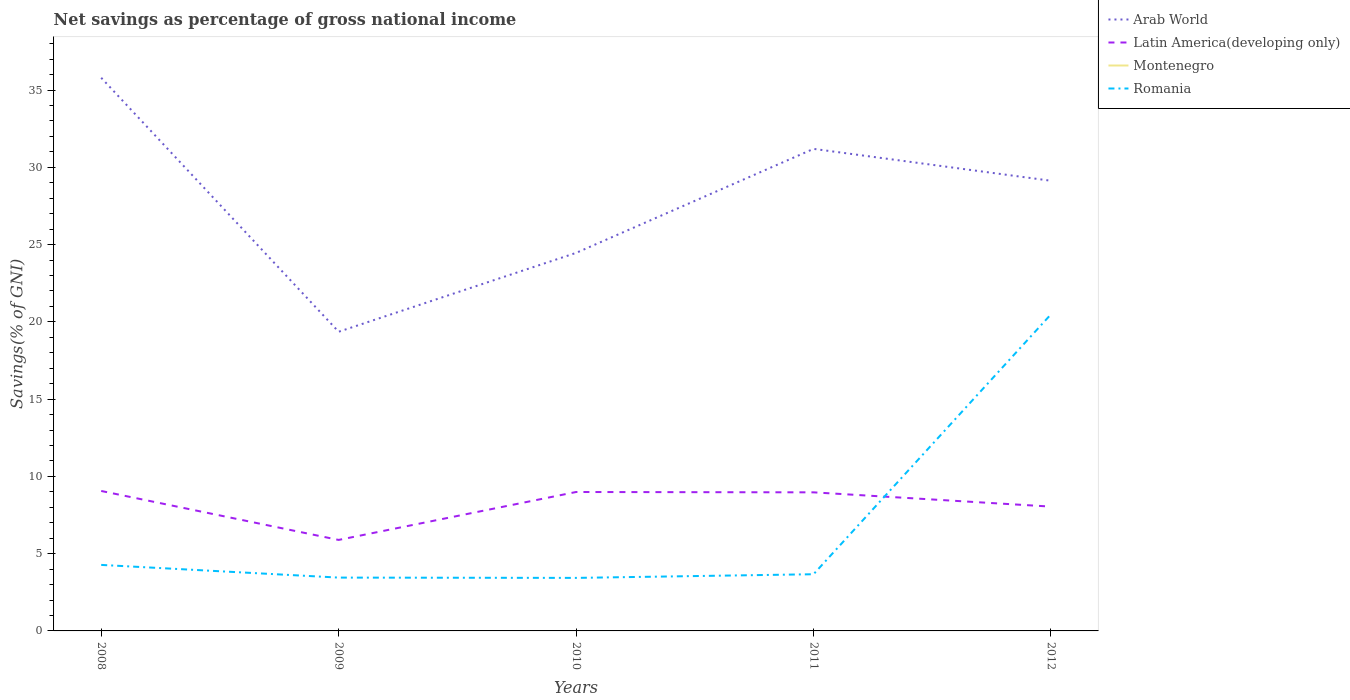Across all years, what is the maximum total savings in Romania?
Make the answer very short. 3.43. What is the total total savings in Arab World in the graph?
Make the answer very short. 6.66. What is the difference between the highest and the second highest total savings in Latin America(developing only)?
Keep it short and to the point. 3.17. What is the difference between two consecutive major ticks on the Y-axis?
Provide a succinct answer. 5. Are the values on the major ticks of Y-axis written in scientific E-notation?
Offer a terse response. No. Does the graph contain any zero values?
Offer a very short reply. Yes. Does the graph contain grids?
Your answer should be very brief. No. Where does the legend appear in the graph?
Give a very brief answer. Top right. How many legend labels are there?
Provide a short and direct response. 4. What is the title of the graph?
Keep it short and to the point. Net savings as percentage of gross national income. What is the label or title of the Y-axis?
Your answer should be very brief. Savings(% of GNI). What is the Savings(% of GNI) of Arab World in 2008?
Offer a terse response. 35.79. What is the Savings(% of GNI) in Latin America(developing only) in 2008?
Your answer should be compact. 9.06. What is the Savings(% of GNI) in Romania in 2008?
Ensure brevity in your answer.  4.27. What is the Savings(% of GNI) in Arab World in 2009?
Give a very brief answer. 19.36. What is the Savings(% of GNI) of Latin America(developing only) in 2009?
Your answer should be compact. 5.89. What is the Savings(% of GNI) of Montenegro in 2009?
Your answer should be very brief. 0. What is the Savings(% of GNI) in Romania in 2009?
Offer a terse response. 3.45. What is the Savings(% of GNI) of Arab World in 2010?
Ensure brevity in your answer.  24.46. What is the Savings(% of GNI) of Latin America(developing only) in 2010?
Offer a terse response. 8.99. What is the Savings(% of GNI) in Montenegro in 2010?
Your answer should be very brief. 0. What is the Savings(% of GNI) of Romania in 2010?
Ensure brevity in your answer.  3.43. What is the Savings(% of GNI) of Arab World in 2011?
Keep it short and to the point. 31.19. What is the Savings(% of GNI) in Latin America(developing only) in 2011?
Give a very brief answer. 8.97. What is the Savings(% of GNI) in Montenegro in 2011?
Offer a very short reply. 0. What is the Savings(% of GNI) of Romania in 2011?
Give a very brief answer. 3.67. What is the Savings(% of GNI) in Arab World in 2012?
Give a very brief answer. 29.13. What is the Savings(% of GNI) of Latin America(developing only) in 2012?
Give a very brief answer. 8.04. What is the Savings(% of GNI) of Montenegro in 2012?
Your answer should be compact. 0. What is the Savings(% of GNI) of Romania in 2012?
Ensure brevity in your answer.  20.49. Across all years, what is the maximum Savings(% of GNI) in Arab World?
Offer a terse response. 35.79. Across all years, what is the maximum Savings(% of GNI) in Latin America(developing only)?
Your response must be concise. 9.06. Across all years, what is the maximum Savings(% of GNI) in Romania?
Ensure brevity in your answer.  20.49. Across all years, what is the minimum Savings(% of GNI) in Arab World?
Ensure brevity in your answer.  19.36. Across all years, what is the minimum Savings(% of GNI) of Latin America(developing only)?
Your answer should be compact. 5.89. Across all years, what is the minimum Savings(% of GNI) of Romania?
Your answer should be compact. 3.43. What is the total Savings(% of GNI) in Arab World in the graph?
Make the answer very short. 139.93. What is the total Savings(% of GNI) of Latin America(developing only) in the graph?
Give a very brief answer. 40.94. What is the total Savings(% of GNI) of Montenegro in the graph?
Provide a short and direct response. 0. What is the total Savings(% of GNI) of Romania in the graph?
Provide a short and direct response. 35.31. What is the difference between the Savings(% of GNI) in Arab World in 2008 and that in 2009?
Offer a terse response. 16.43. What is the difference between the Savings(% of GNI) in Latin America(developing only) in 2008 and that in 2009?
Offer a very short reply. 3.17. What is the difference between the Savings(% of GNI) in Romania in 2008 and that in 2009?
Your answer should be very brief. 0.82. What is the difference between the Savings(% of GNI) in Arab World in 2008 and that in 2010?
Make the answer very short. 11.33. What is the difference between the Savings(% of GNI) of Latin America(developing only) in 2008 and that in 2010?
Ensure brevity in your answer.  0.07. What is the difference between the Savings(% of GNI) of Romania in 2008 and that in 2010?
Ensure brevity in your answer.  0.84. What is the difference between the Savings(% of GNI) in Arab World in 2008 and that in 2011?
Your answer should be compact. 4.6. What is the difference between the Savings(% of GNI) of Latin America(developing only) in 2008 and that in 2011?
Your response must be concise. 0.09. What is the difference between the Savings(% of GNI) in Romania in 2008 and that in 2011?
Your answer should be very brief. 0.6. What is the difference between the Savings(% of GNI) in Arab World in 2008 and that in 2012?
Provide a short and direct response. 6.66. What is the difference between the Savings(% of GNI) of Latin America(developing only) in 2008 and that in 2012?
Your answer should be compact. 1.01. What is the difference between the Savings(% of GNI) of Romania in 2008 and that in 2012?
Provide a short and direct response. -16.22. What is the difference between the Savings(% of GNI) of Arab World in 2009 and that in 2010?
Provide a short and direct response. -5.1. What is the difference between the Savings(% of GNI) of Latin America(developing only) in 2009 and that in 2010?
Your answer should be very brief. -3.1. What is the difference between the Savings(% of GNI) in Romania in 2009 and that in 2010?
Keep it short and to the point. 0.02. What is the difference between the Savings(% of GNI) of Arab World in 2009 and that in 2011?
Give a very brief answer. -11.83. What is the difference between the Savings(% of GNI) in Latin America(developing only) in 2009 and that in 2011?
Provide a short and direct response. -3.08. What is the difference between the Savings(% of GNI) of Romania in 2009 and that in 2011?
Provide a short and direct response. -0.22. What is the difference between the Savings(% of GNI) of Arab World in 2009 and that in 2012?
Your answer should be very brief. -9.77. What is the difference between the Savings(% of GNI) of Latin America(developing only) in 2009 and that in 2012?
Provide a succinct answer. -2.16. What is the difference between the Savings(% of GNI) in Romania in 2009 and that in 2012?
Your answer should be compact. -17.04. What is the difference between the Savings(% of GNI) of Arab World in 2010 and that in 2011?
Your response must be concise. -6.73. What is the difference between the Savings(% of GNI) in Latin America(developing only) in 2010 and that in 2011?
Offer a terse response. 0.02. What is the difference between the Savings(% of GNI) of Romania in 2010 and that in 2011?
Ensure brevity in your answer.  -0.24. What is the difference between the Savings(% of GNI) of Arab World in 2010 and that in 2012?
Ensure brevity in your answer.  -4.67. What is the difference between the Savings(% of GNI) of Latin America(developing only) in 2010 and that in 2012?
Provide a succinct answer. 0.95. What is the difference between the Savings(% of GNI) in Romania in 2010 and that in 2012?
Provide a short and direct response. -17.06. What is the difference between the Savings(% of GNI) of Arab World in 2011 and that in 2012?
Your answer should be compact. 2.06. What is the difference between the Savings(% of GNI) in Latin America(developing only) in 2011 and that in 2012?
Keep it short and to the point. 0.92. What is the difference between the Savings(% of GNI) of Romania in 2011 and that in 2012?
Keep it short and to the point. -16.82. What is the difference between the Savings(% of GNI) in Arab World in 2008 and the Savings(% of GNI) in Latin America(developing only) in 2009?
Give a very brief answer. 29.9. What is the difference between the Savings(% of GNI) of Arab World in 2008 and the Savings(% of GNI) of Romania in 2009?
Your answer should be very brief. 32.34. What is the difference between the Savings(% of GNI) in Latin America(developing only) in 2008 and the Savings(% of GNI) in Romania in 2009?
Offer a very short reply. 5.61. What is the difference between the Savings(% of GNI) in Arab World in 2008 and the Savings(% of GNI) in Latin America(developing only) in 2010?
Provide a succinct answer. 26.8. What is the difference between the Savings(% of GNI) in Arab World in 2008 and the Savings(% of GNI) in Romania in 2010?
Offer a very short reply. 32.36. What is the difference between the Savings(% of GNI) in Latin America(developing only) in 2008 and the Savings(% of GNI) in Romania in 2010?
Offer a terse response. 5.62. What is the difference between the Savings(% of GNI) in Arab World in 2008 and the Savings(% of GNI) in Latin America(developing only) in 2011?
Make the answer very short. 26.82. What is the difference between the Savings(% of GNI) in Arab World in 2008 and the Savings(% of GNI) in Romania in 2011?
Your response must be concise. 32.12. What is the difference between the Savings(% of GNI) in Latin America(developing only) in 2008 and the Savings(% of GNI) in Romania in 2011?
Offer a very short reply. 5.39. What is the difference between the Savings(% of GNI) of Arab World in 2008 and the Savings(% of GNI) of Latin America(developing only) in 2012?
Keep it short and to the point. 27.75. What is the difference between the Savings(% of GNI) in Arab World in 2008 and the Savings(% of GNI) in Romania in 2012?
Offer a very short reply. 15.31. What is the difference between the Savings(% of GNI) in Latin America(developing only) in 2008 and the Savings(% of GNI) in Romania in 2012?
Keep it short and to the point. -11.43. What is the difference between the Savings(% of GNI) of Arab World in 2009 and the Savings(% of GNI) of Latin America(developing only) in 2010?
Give a very brief answer. 10.37. What is the difference between the Savings(% of GNI) in Arab World in 2009 and the Savings(% of GNI) in Romania in 2010?
Your answer should be compact. 15.93. What is the difference between the Savings(% of GNI) of Latin America(developing only) in 2009 and the Savings(% of GNI) of Romania in 2010?
Give a very brief answer. 2.46. What is the difference between the Savings(% of GNI) in Arab World in 2009 and the Savings(% of GNI) in Latin America(developing only) in 2011?
Offer a terse response. 10.39. What is the difference between the Savings(% of GNI) in Arab World in 2009 and the Savings(% of GNI) in Romania in 2011?
Provide a succinct answer. 15.69. What is the difference between the Savings(% of GNI) in Latin America(developing only) in 2009 and the Savings(% of GNI) in Romania in 2011?
Provide a short and direct response. 2.22. What is the difference between the Savings(% of GNI) in Arab World in 2009 and the Savings(% of GNI) in Latin America(developing only) in 2012?
Give a very brief answer. 11.31. What is the difference between the Savings(% of GNI) in Arab World in 2009 and the Savings(% of GNI) in Romania in 2012?
Make the answer very short. -1.13. What is the difference between the Savings(% of GNI) in Latin America(developing only) in 2009 and the Savings(% of GNI) in Romania in 2012?
Offer a terse response. -14.6. What is the difference between the Savings(% of GNI) of Arab World in 2010 and the Savings(% of GNI) of Latin America(developing only) in 2011?
Provide a short and direct response. 15.49. What is the difference between the Savings(% of GNI) in Arab World in 2010 and the Savings(% of GNI) in Romania in 2011?
Provide a short and direct response. 20.79. What is the difference between the Savings(% of GNI) in Latin America(developing only) in 2010 and the Savings(% of GNI) in Romania in 2011?
Provide a succinct answer. 5.32. What is the difference between the Savings(% of GNI) in Arab World in 2010 and the Savings(% of GNI) in Latin America(developing only) in 2012?
Offer a very short reply. 16.42. What is the difference between the Savings(% of GNI) in Arab World in 2010 and the Savings(% of GNI) in Romania in 2012?
Provide a short and direct response. 3.97. What is the difference between the Savings(% of GNI) of Latin America(developing only) in 2010 and the Savings(% of GNI) of Romania in 2012?
Offer a very short reply. -11.5. What is the difference between the Savings(% of GNI) in Arab World in 2011 and the Savings(% of GNI) in Latin America(developing only) in 2012?
Offer a very short reply. 23.15. What is the difference between the Savings(% of GNI) of Arab World in 2011 and the Savings(% of GNI) of Romania in 2012?
Offer a very short reply. 10.7. What is the difference between the Savings(% of GNI) of Latin America(developing only) in 2011 and the Savings(% of GNI) of Romania in 2012?
Offer a very short reply. -11.52. What is the average Savings(% of GNI) in Arab World per year?
Provide a succinct answer. 27.99. What is the average Savings(% of GNI) of Latin America(developing only) per year?
Keep it short and to the point. 8.19. What is the average Savings(% of GNI) of Montenegro per year?
Ensure brevity in your answer.  0. What is the average Savings(% of GNI) in Romania per year?
Offer a very short reply. 7.06. In the year 2008, what is the difference between the Savings(% of GNI) in Arab World and Savings(% of GNI) in Latin America(developing only)?
Your answer should be very brief. 26.74. In the year 2008, what is the difference between the Savings(% of GNI) in Arab World and Savings(% of GNI) in Romania?
Make the answer very short. 31.52. In the year 2008, what is the difference between the Savings(% of GNI) of Latin America(developing only) and Savings(% of GNI) of Romania?
Ensure brevity in your answer.  4.78. In the year 2009, what is the difference between the Savings(% of GNI) in Arab World and Savings(% of GNI) in Latin America(developing only)?
Your response must be concise. 13.47. In the year 2009, what is the difference between the Savings(% of GNI) in Arab World and Savings(% of GNI) in Romania?
Make the answer very short. 15.91. In the year 2009, what is the difference between the Savings(% of GNI) in Latin America(developing only) and Savings(% of GNI) in Romania?
Your answer should be very brief. 2.44. In the year 2010, what is the difference between the Savings(% of GNI) of Arab World and Savings(% of GNI) of Latin America(developing only)?
Your response must be concise. 15.47. In the year 2010, what is the difference between the Savings(% of GNI) in Arab World and Savings(% of GNI) in Romania?
Give a very brief answer. 21.03. In the year 2010, what is the difference between the Savings(% of GNI) in Latin America(developing only) and Savings(% of GNI) in Romania?
Provide a succinct answer. 5.56. In the year 2011, what is the difference between the Savings(% of GNI) in Arab World and Savings(% of GNI) in Latin America(developing only)?
Provide a succinct answer. 22.22. In the year 2011, what is the difference between the Savings(% of GNI) of Arab World and Savings(% of GNI) of Romania?
Give a very brief answer. 27.52. In the year 2011, what is the difference between the Savings(% of GNI) of Latin America(developing only) and Savings(% of GNI) of Romania?
Your response must be concise. 5.3. In the year 2012, what is the difference between the Savings(% of GNI) in Arab World and Savings(% of GNI) in Latin America(developing only)?
Give a very brief answer. 21.08. In the year 2012, what is the difference between the Savings(% of GNI) in Arab World and Savings(% of GNI) in Romania?
Your response must be concise. 8.64. In the year 2012, what is the difference between the Savings(% of GNI) of Latin America(developing only) and Savings(% of GNI) of Romania?
Your answer should be compact. -12.44. What is the ratio of the Savings(% of GNI) of Arab World in 2008 to that in 2009?
Your response must be concise. 1.85. What is the ratio of the Savings(% of GNI) in Latin America(developing only) in 2008 to that in 2009?
Keep it short and to the point. 1.54. What is the ratio of the Savings(% of GNI) of Romania in 2008 to that in 2009?
Keep it short and to the point. 1.24. What is the ratio of the Savings(% of GNI) in Arab World in 2008 to that in 2010?
Ensure brevity in your answer.  1.46. What is the ratio of the Savings(% of GNI) in Latin America(developing only) in 2008 to that in 2010?
Give a very brief answer. 1.01. What is the ratio of the Savings(% of GNI) of Romania in 2008 to that in 2010?
Offer a terse response. 1.24. What is the ratio of the Savings(% of GNI) in Arab World in 2008 to that in 2011?
Give a very brief answer. 1.15. What is the ratio of the Savings(% of GNI) in Latin America(developing only) in 2008 to that in 2011?
Your answer should be very brief. 1.01. What is the ratio of the Savings(% of GNI) of Romania in 2008 to that in 2011?
Your answer should be compact. 1.16. What is the ratio of the Savings(% of GNI) of Arab World in 2008 to that in 2012?
Give a very brief answer. 1.23. What is the ratio of the Savings(% of GNI) of Latin America(developing only) in 2008 to that in 2012?
Provide a short and direct response. 1.13. What is the ratio of the Savings(% of GNI) of Romania in 2008 to that in 2012?
Give a very brief answer. 0.21. What is the ratio of the Savings(% of GNI) in Arab World in 2009 to that in 2010?
Offer a very short reply. 0.79. What is the ratio of the Savings(% of GNI) of Latin America(developing only) in 2009 to that in 2010?
Your response must be concise. 0.66. What is the ratio of the Savings(% of GNI) in Arab World in 2009 to that in 2011?
Provide a short and direct response. 0.62. What is the ratio of the Savings(% of GNI) of Latin America(developing only) in 2009 to that in 2011?
Your answer should be very brief. 0.66. What is the ratio of the Savings(% of GNI) in Romania in 2009 to that in 2011?
Provide a succinct answer. 0.94. What is the ratio of the Savings(% of GNI) of Arab World in 2009 to that in 2012?
Make the answer very short. 0.66. What is the ratio of the Savings(% of GNI) of Latin America(developing only) in 2009 to that in 2012?
Keep it short and to the point. 0.73. What is the ratio of the Savings(% of GNI) in Romania in 2009 to that in 2012?
Your response must be concise. 0.17. What is the ratio of the Savings(% of GNI) in Arab World in 2010 to that in 2011?
Your answer should be very brief. 0.78. What is the ratio of the Savings(% of GNI) of Latin America(developing only) in 2010 to that in 2011?
Provide a succinct answer. 1. What is the ratio of the Savings(% of GNI) of Romania in 2010 to that in 2011?
Your answer should be very brief. 0.94. What is the ratio of the Savings(% of GNI) in Arab World in 2010 to that in 2012?
Make the answer very short. 0.84. What is the ratio of the Savings(% of GNI) in Latin America(developing only) in 2010 to that in 2012?
Provide a short and direct response. 1.12. What is the ratio of the Savings(% of GNI) of Romania in 2010 to that in 2012?
Keep it short and to the point. 0.17. What is the ratio of the Savings(% of GNI) in Arab World in 2011 to that in 2012?
Keep it short and to the point. 1.07. What is the ratio of the Savings(% of GNI) of Latin America(developing only) in 2011 to that in 2012?
Offer a very short reply. 1.11. What is the ratio of the Savings(% of GNI) in Romania in 2011 to that in 2012?
Provide a short and direct response. 0.18. What is the difference between the highest and the second highest Savings(% of GNI) of Arab World?
Give a very brief answer. 4.6. What is the difference between the highest and the second highest Savings(% of GNI) in Latin America(developing only)?
Keep it short and to the point. 0.07. What is the difference between the highest and the second highest Savings(% of GNI) of Romania?
Your answer should be compact. 16.22. What is the difference between the highest and the lowest Savings(% of GNI) of Arab World?
Give a very brief answer. 16.43. What is the difference between the highest and the lowest Savings(% of GNI) of Latin America(developing only)?
Your answer should be compact. 3.17. What is the difference between the highest and the lowest Savings(% of GNI) of Romania?
Provide a succinct answer. 17.06. 